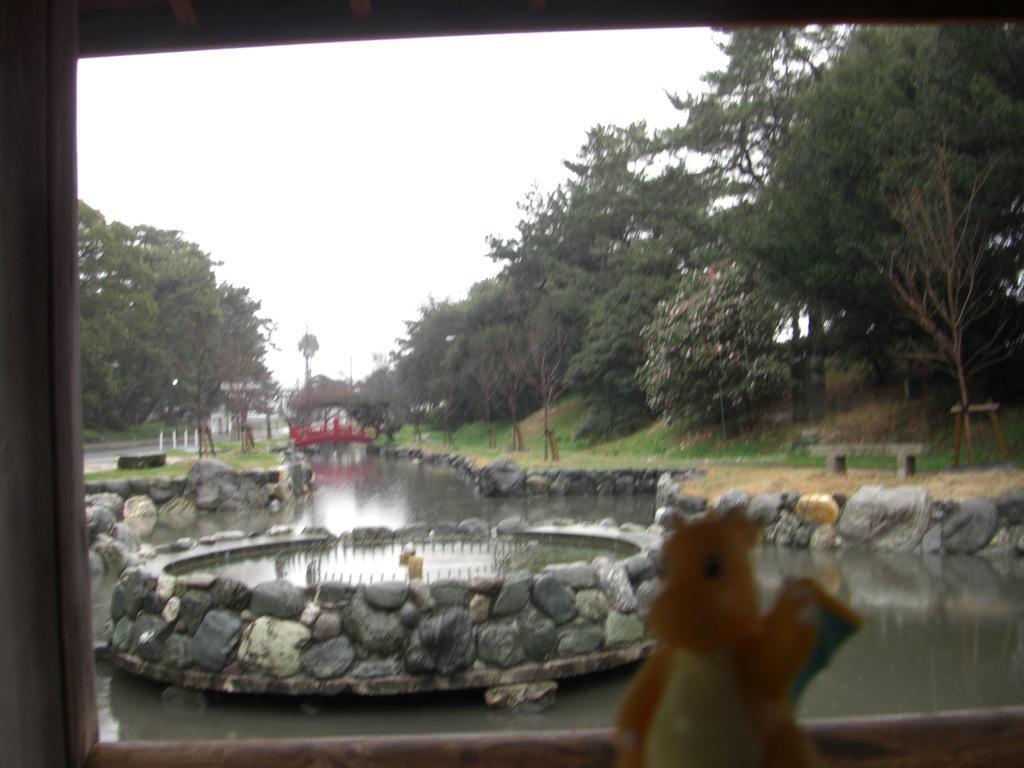Can you describe this image briefly? In this picture we can see a toy, water and few rocks, in the background we can see grass and few trees. 